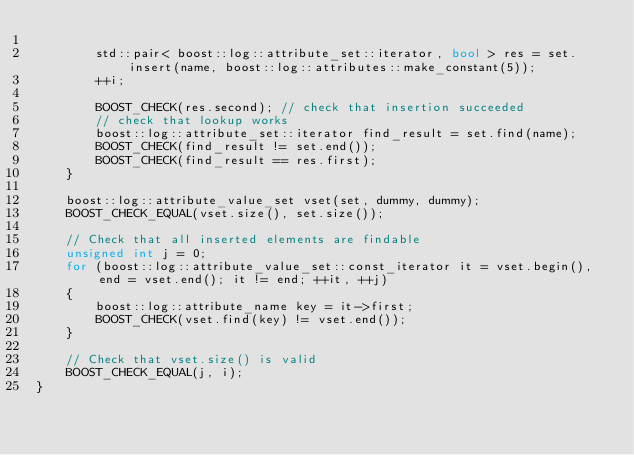<code> <loc_0><loc_0><loc_500><loc_500><_C++_>
        std::pair< boost::log::attribute_set::iterator, bool > res = set.insert(name, boost::log::attributes::make_constant(5));
        ++i;

        BOOST_CHECK(res.second); // check that insertion succeeded
        // check that lookup works
        boost::log::attribute_set::iterator find_result = set.find(name);
        BOOST_CHECK(find_result != set.end());
        BOOST_CHECK(find_result == res.first);
    }

    boost::log::attribute_value_set vset(set, dummy, dummy);
    BOOST_CHECK_EQUAL(vset.size(), set.size());

    // Check that all inserted elements are findable
    unsigned int j = 0;
    for (boost::log::attribute_value_set::const_iterator it = vset.begin(), end = vset.end(); it != end; ++it, ++j)
    {
        boost::log::attribute_name key = it->first;
        BOOST_CHECK(vset.find(key) != vset.end());
    }

    // Check that vset.size() is valid
    BOOST_CHECK_EQUAL(j, i);
}
</code> 